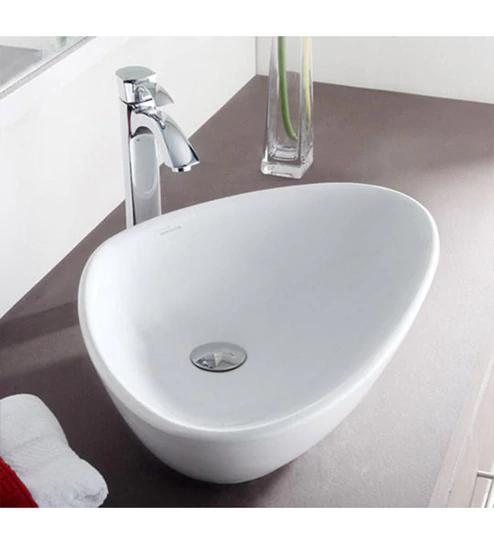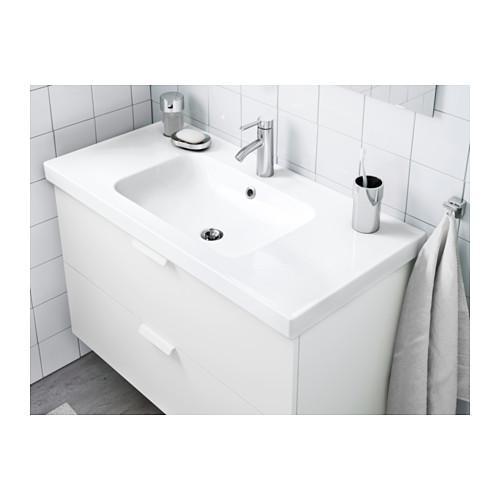The first image is the image on the left, the second image is the image on the right. Evaluate the accuracy of this statement regarding the images: "The two images show a somewhat round bowl sink and a rectangular inset sink.". Is it true? Answer yes or no. Yes. 